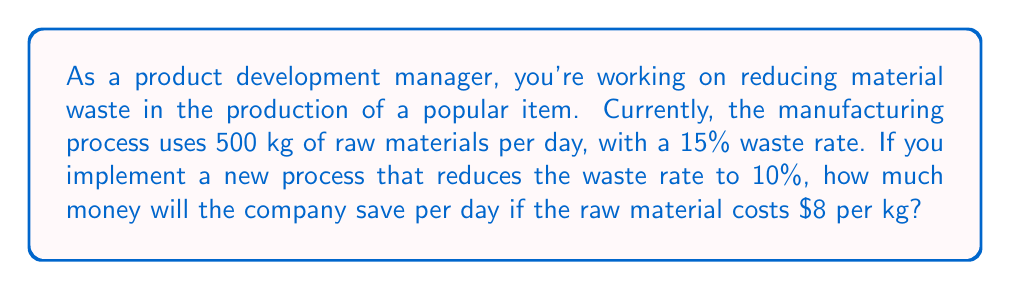Solve this math problem. Let's approach this problem step by step:

1. Calculate the current amount of waste:
   Current waste = 15% of 500 kg
   $$ \text{Current waste} = 0.15 \times 500 \text{ kg} = 75 \text{ kg} $$

2. Calculate the amount of waste after implementing the new process:
   New waste = 10% of 500 kg
   $$ \text{New waste} = 0.10 \times 500 \text{ kg} = 50 \text{ kg} $$

3. Calculate the reduction in waste:
   $$ \text{Waste reduction} = \text{Current waste} - \text{New waste} $$
   $$ \text{Waste reduction} = 75 \text{ kg} - 50 \text{ kg} = 25 \text{ kg} $$

4. Calculate the cost savings:
   Cost savings = Waste reduction × Cost per kg
   $$ \text{Cost savings} = 25 \text{ kg} \times \$8/\text{kg} = \$200 $$

Therefore, the company will save $200 per day by implementing the new process that reduces the waste rate from 15% to 10%.
Answer: $200 per day 